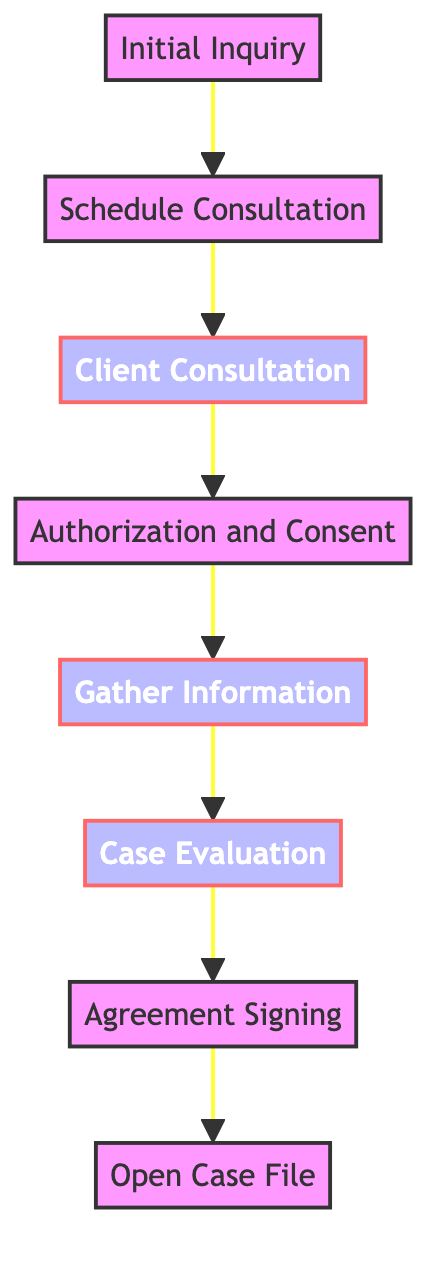What is the first step in the legal case intake process? The first step in the process as depicted in the diagram is "Initial Inquiry." This is the starting point where the interaction begins, leading to all subsequent steps.
Answer: Initial Inquiry How many steps are there in the legal case intake process? By counting the nodes in the flowchart, there are a total of eight steps from "Initial Inquiry" to "Open Case File." Each step represents a specific part of the intake process.
Answer: 8 What step follows "Client Consultation"? In the flowchart, after "Client Consultation," the next step is "Authorization and Consent." This relationship shows the progression from understanding the client's needs to obtaining necessary permissions.
Answer: Authorization and Consent Which steps involve document collection or signing? The steps that involve document collection or signing are "Gather Information" and "Agreement Signing." These steps focus respectively on collecting necessary documents and securing client agreements for legal representation.
Answer: Gather Information, Agreement Signing What is the role of "Case Evaluation" in the process? "Case Evaluation" serves as a critical review stage where all collected information is evaluated to assess the legal merits of the case. It's essential for determining how to proceed further in the legal process.
Answer: Evaluate legal merits Which step comes after obtaining consent? After obtaining "Authorization and Consent," the next step in the flowchart is "Gather Information." This indicates that consent is needed before collecting relevant documents for the case.
Answer: Gather Information What type of node is "Client Consultation"? In the diagram, "Client Consultation" is classified as a process node. This means it is an essential operational step in the intake process rather than merely a transition point or an administrative task.
Answer: process Is "Open Case File" the final step? Yes, "Open Case File" is the last step in the flow of the legal case intake process as indicated in the flowchart. This final action indicates that all prior steps have been completed, and the case is ready to be managed.
Answer: Yes 